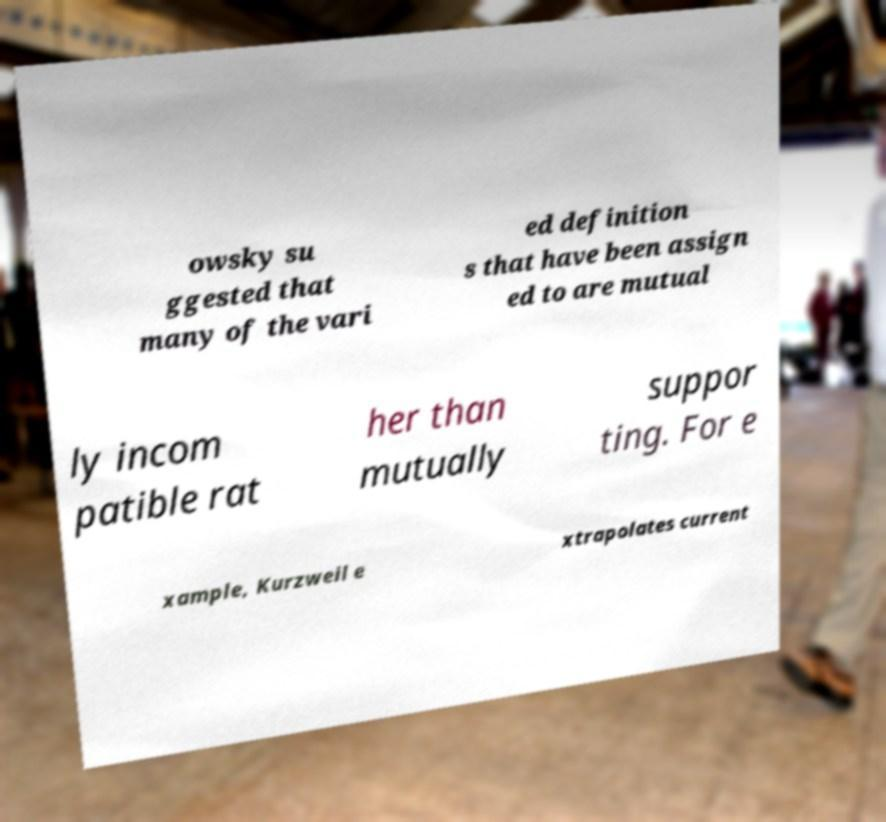There's text embedded in this image that I need extracted. Can you transcribe it verbatim? owsky su ggested that many of the vari ed definition s that have been assign ed to are mutual ly incom patible rat her than mutually suppor ting. For e xample, Kurzweil e xtrapolates current 